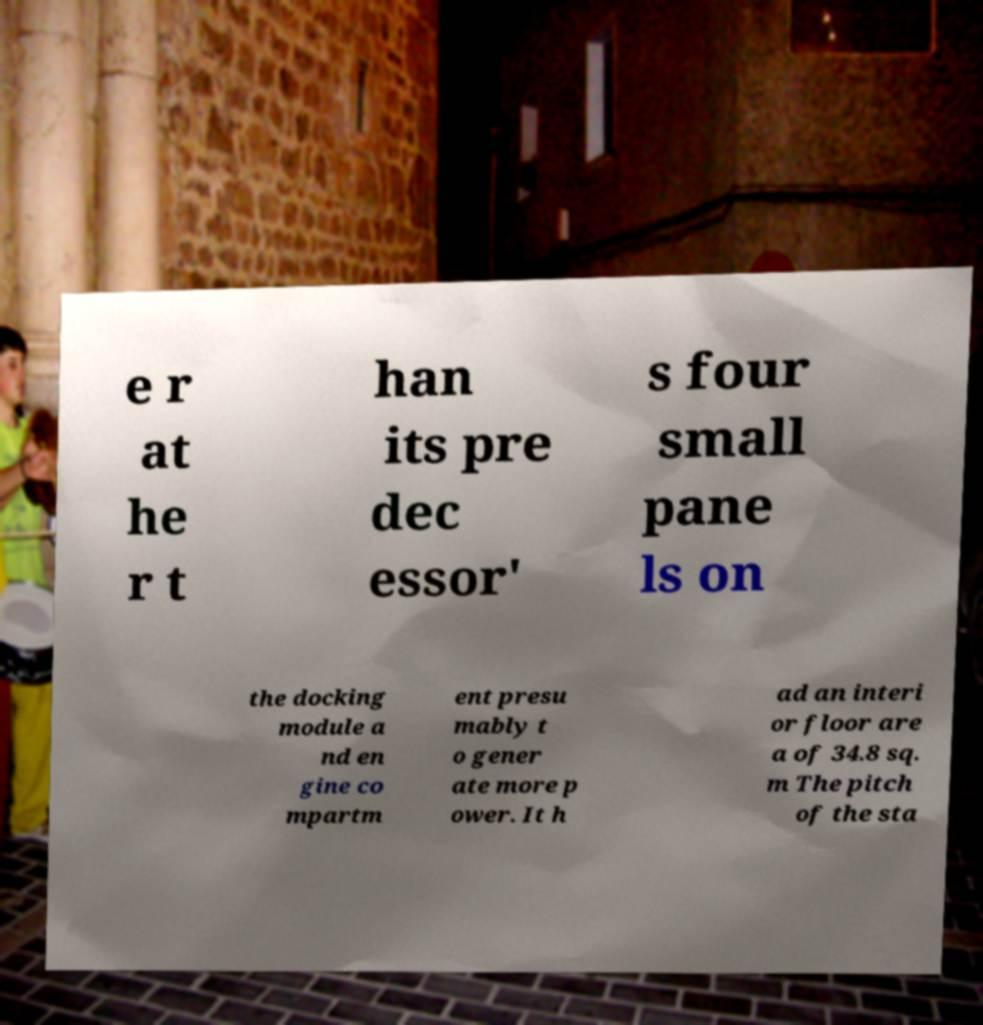I need the written content from this picture converted into text. Can you do that? e r at he r t han its pre dec essor' s four small pane ls on the docking module a nd en gine co mpartm ent presu mably t o gener ate more p ower. It h ad an interi or floor are a of 34.8 sq. m The pitch of the sta 